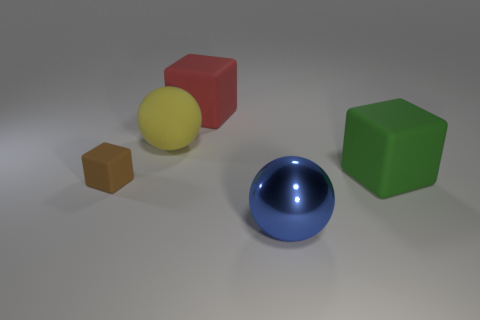Is there anything else that is made of the same material as the big blue ball?
Provide a short and direct response. No. What is the color of the matte block that is on the left side of the large yellow sphere on the left side of the blue ball?
Your answer should be very brief. Brown. There is a metallic ball that is the same size as the green rubber object; what color is it?
Your response must be concise. Blue. Is there a small metal thing that has the same color as the tiny rubber cube?
Your answer should be very brief. No. Are there any big green blocks?
Make the answer very short. Yes. What shape is the big matte thing that is in front of the yellow matte sphere?
Offer a very short reply. Cube. How many things are both in front of the large red rubber cube and behind the green block?
Give a very brief answer. 1. What number of other objects are the same size as the brown matte object?
Your response must be concise. 0. Do the thing to the left of the yellow rubber thing and the blue metal thing that is in front of the yellow rubber thing have the same shape?
Give a very brief answer. No. What number of things are big rubber cylinders or cubes to the left of the green matte cube?
Keep it short and to the point. 2. 